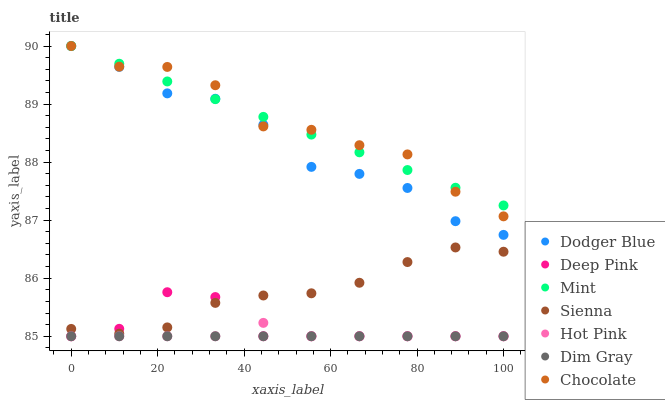Does Dim Gray have the minimum area under the curve?
Answer yes or no. Yes. Does Chocolate have the maximum area under the curve?
Answer yes or no. Yes. Does Hot Pink have the minimum area under the curve?
Answer yes or no. No. Does Hot Pink have the maximum area under the curve?
Answer yes or no. No. Is Dim Gray the smoothest?
Answer yes or no. Yes. Is Chocolate the roughest?
Answer yes or no. Yes. Is Hot Pink the smoothest?
Answer yes or no. No. Is Hot Pink the roughest?
Answer yes or no. No. Does Dim Gray have the lowest value?
Answer yes or no. Yes. Does Chocolate have the lowest value?
Answer yes or no. No. Does Mint have the highest value?
Answer yes or no. Yes. Does Hot Pink have the highest value?
Answer yes or no. No. Is Sienna less than Dodger Blue?
Answer yes or no. Yes. Is Sienna greater than Hot Pink?
Answer yes or no. Yes. Does Chocolate intersect Mint?
Answer yes or no. Yes. Is Chocolate less than Mint?
Answer yes or no. No. Is Chocolate greater than Mint?
Answer yes or no. No. Does Sienna intersect Dodger Blue?
Answer yes or no. No. 